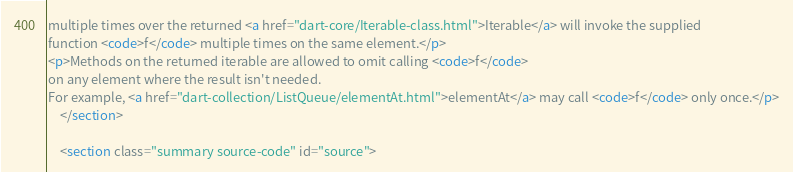Convert code to text. <code><loc_0><loc_0><loc_500><loc_500><_HTML_>multiple times over the returned <a href="dart-core/Iterable-class.html">Iterable</a> will invoke the supplied
function <code>f</code> multiple times on the same element.</p>
<p>Methods on the returned iterable are allowed to omit calling <code>f</code>
on any element where the result isn't needed.
For example, <a href="dart-collection/ListQueue/elementAt.html">elementAt</a> may call <code>f</code> only once.</p>
    </section>
    
    <section class="summary source-code" id="source"></code> 